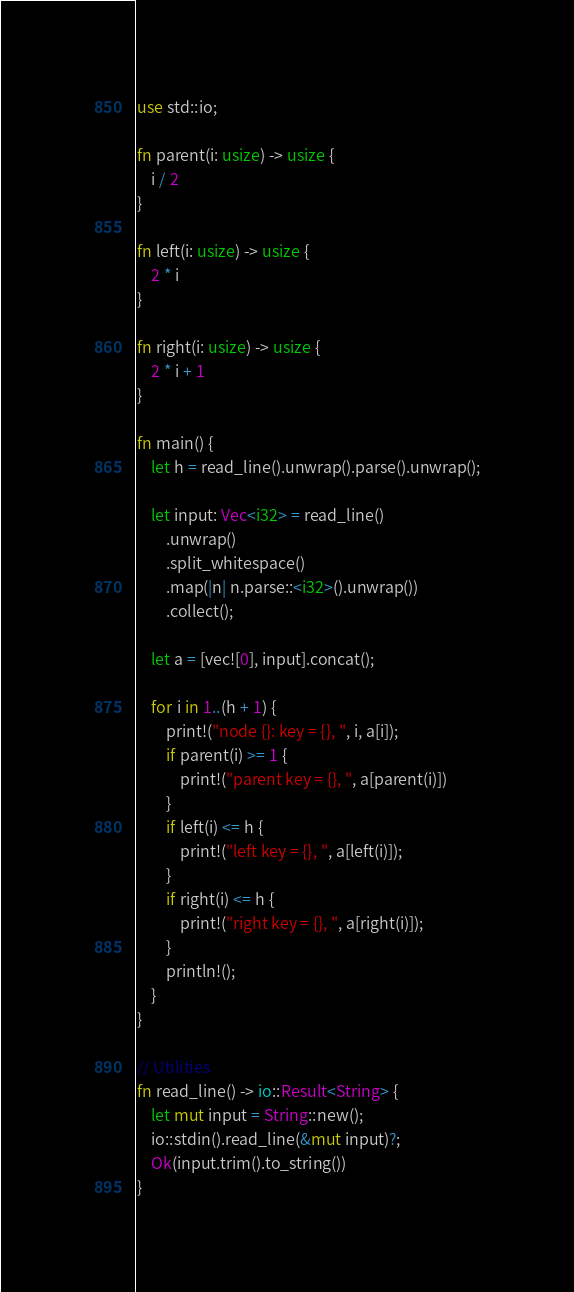Convert code to text. <code><loc_0><loc_0><loc_500><loc_500><_Rust_>use std::io;

fn parent(i: usize) -> usize {
    i / 2
}

fn left(i: usize) -> usize {
    2 * i
}

fn right(i: usize) -> usize {
    2 * i + 1
}

fn main() {
    let h = read_line().unwrap().parse().unwrap();

    let input: Vec<i32> = read_line()
        .unwrap()
        .split_whitespace()
        .map(|n| n.parse::<i32>().unwrap())
        .collect();

    let a = [vec![0], input].concat();

    for i in 1..(h + 1) {
        print!("node {}: key = {}, ", i, a[i]);
        if parent(i) >= 1 {
            print!("parent key = {}, ", a[parent(i)])
        }
        if left(i) <= h {
            print!("left key = {}, ", a[left(i)]);
        }
        if right(i) <= h {
            print!("right key = {}, ", a[right(i)]);
        }
        println!();
    }
}

// Utilities
fn read_line() -> io::Result<String> {
    let mut input = String::new();
    io::stdin().read_line(&mut input)?;
    Ok(input.trim().to_string())
}

</code> 